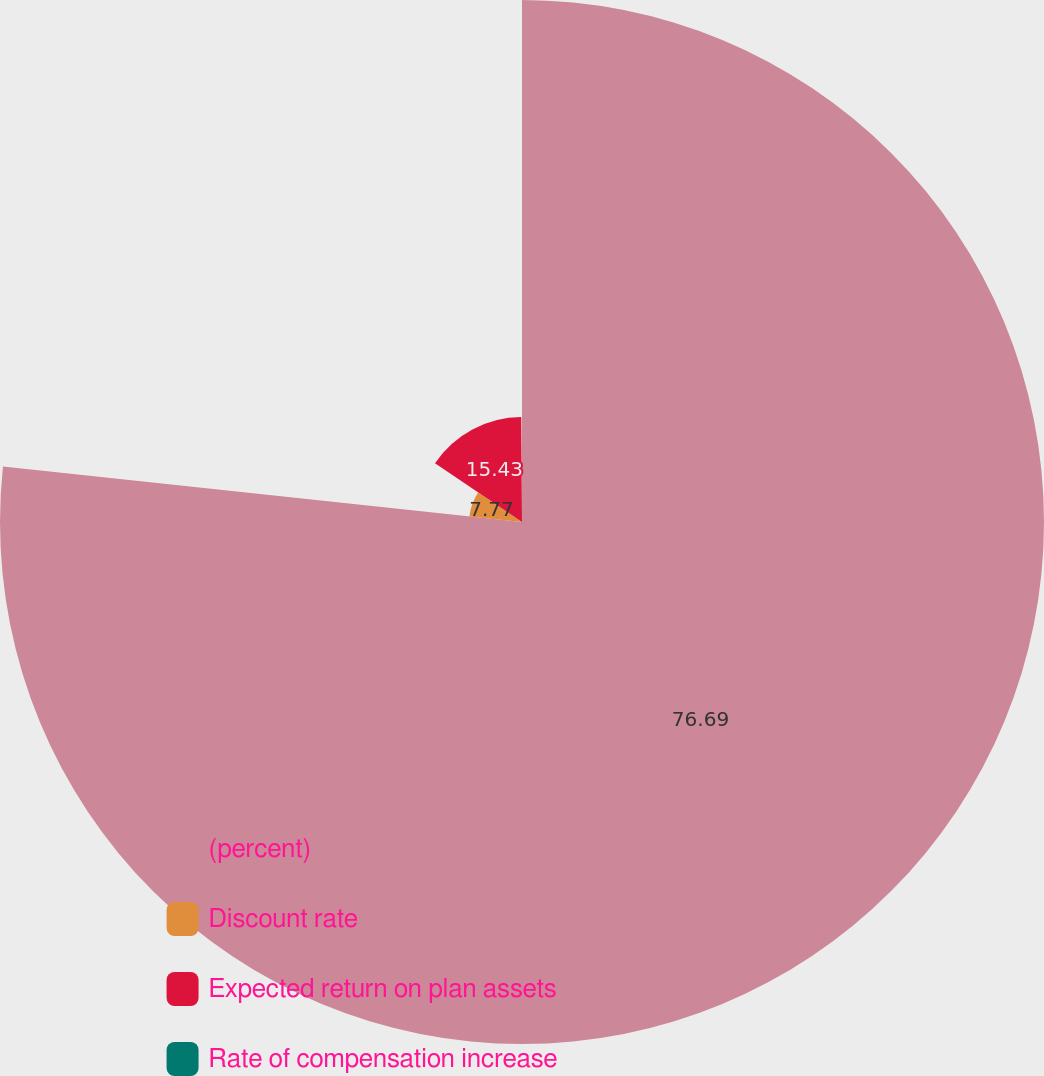<chart> <loc_0><loc_0><loc_500><loc_500><pie_chart><fcel>(percent)<fcel>Discount rate<fcel>Expected return on plan assets<fcel>Rate of compensation increase<nl><fcel>76.7%<fcel>7.77%<fcel>15.43%<fcel>0.11%<nl></chart> 